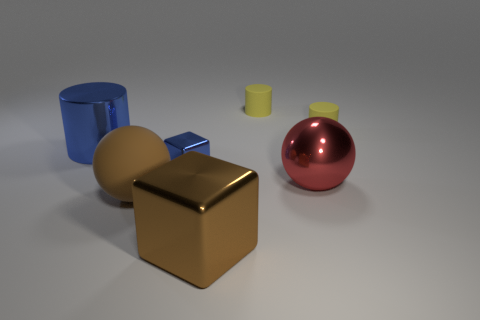Add 3 big metallic cylinders. How many objects exist? 10 Subtract all blue shiny cylinders. How many cylinders are left? 2 Subtract all blue cubes. How many cubes are left? 1 Subtract 2 balls. How many balls are left? 0 Add 5 metallic cylinders. How many metallic cylinders are left? 6 Add 4 tiny yellow cylinders. How many tiny yellow cylinders exist? 6 Subtract 0 gray blocks. How many objects are left? 7 Subtract all blocks. How many objects are left? 5 Subtract all cyan spheres. Subtract all yellow cylinders. How many spheres are left? 2 Subtract all yellow balls. How many gray cylinders are left? 0 